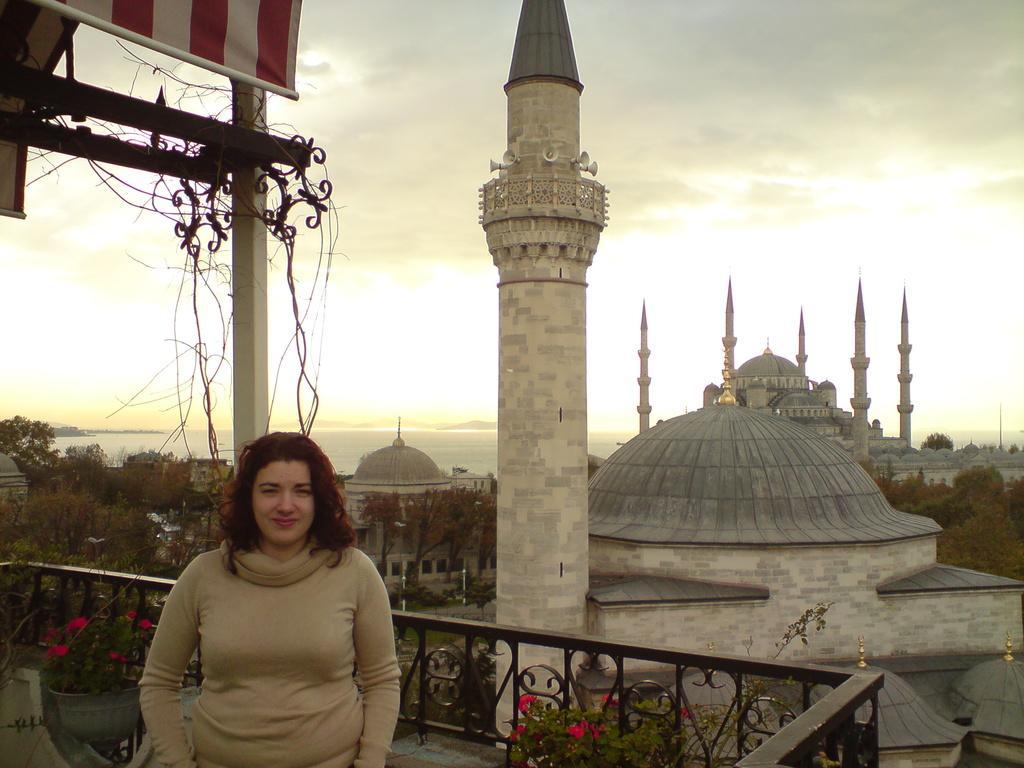Describe this image in one or two sentences. In this image we can see a lady. Near to her there are flowering plants. Also there is a pot and there is a railing. In the back there are buildings with pillars. Also there are megaphones. And there are trees and sky with clouds. Also there is water. 